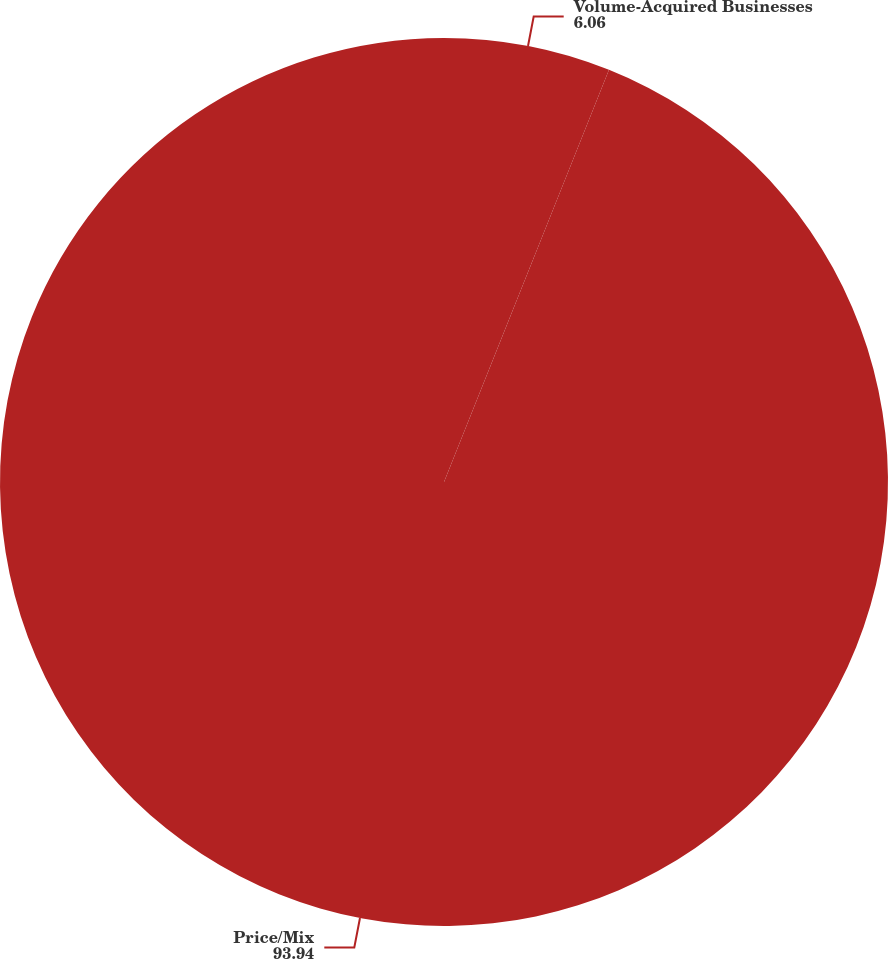Convert chart. <chart><loc_0><loc_0><loc_500><loc_500><pie_chart><fcel>Volume-Acquired Businesses<fcel>Price/Mix<nl><fcel>6.06%<fcel>93.94%<nl></chart> 